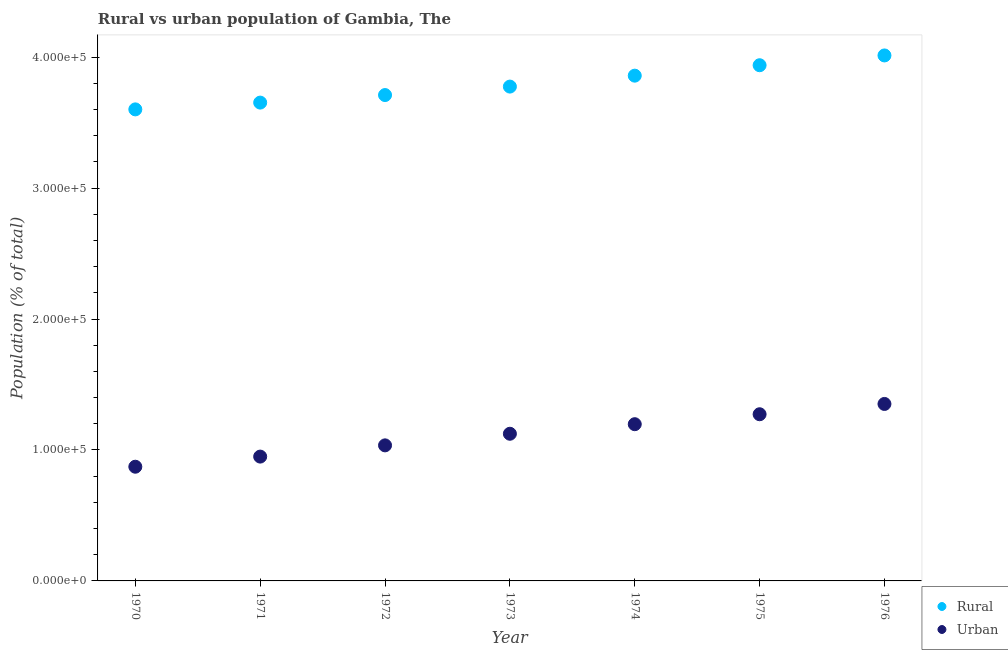What is the rural population density in 1970?
Offer a terse response. 3.60e+05. Across all years, what is the maximum rural population density?
Provide a short and direct response. 4.01e+05. Across all years, what is the minimum urban population density?
Keep it short and to the point. 8.72e+04. In which year was the rural population density maximum?
Ensure brevity in your answer.  1976. What is the total rural population density in the graph?
Your answer should be compact. 2.65e+06. What is the difference between the rural population density in 1972 and that in 1974?
Offer a very short reply. -1.48e+04. What is the difference between the rural population density in 1970 and the urban population density in 1971?
Offer a terse response. 2.65e+05. What is the average urban population density per year?
Offer a terse response. 1.11e+05. In the year 1973, what is the difference between the rural population density and urban population density?
Offer a terse response. 2.65e+05. What is the ratio of the urban population density in 1970 to that in 1975?
Provide a succinct answer. 0.69. Is the urban population density in 1971 less than that in 1976?
Your response must be concise. Yes. Is the difference between the urban population density in 1970 and 1976 greater than the difference between the rural population density in 1970 and 1976?
Your answer should be very brief. No. What is the difference between the highest and the second highest rural population density?
Offer a terse response. 7478. What is the difference between the highest and the lowest rural population density?
Provide a succinct answer. 4.12e+04. In how many years, is the urban population density greater than the average urban population density taken over all years?
Your response must be concise. 4. Is the sum of the rural population density in 1970 and 1972 greater than the maximum urban population density across all years?
Your response must be concise. Yes. Does the urban population density monotonically increase over the years?
Provide a succinct answer. Yes. Is the urban population density strictly greater than the rural population density over the years?
Give a very brief answer. No. Are the values on the major ticks of Y-axis written in scientific E-notation?
Your answer should be very brief. Yes. Does the graph contain any zero values?
Your answer should be very brief. No. How are the legend labels stacked?
Keep it short and to the point. Vertical. What is the title of the graph?
Your response must be concise. Rural vs urban population of Gambia, The. Does "Secondary school" appear as one of the legend labels in the graph?
Make the answer very short. No. What is the label or title of the Y-axis?
Make the answer very short. Population (% of total). What is the Population (% of total) of Rural in 1970?
Provide a short and direct response. 3.60e+05. What is the Population (% of total) in Urban in 1970?
Offer a very short reply. 8.72e+04. What is the Population (% of total) of Rural in 1971?
Provide a succinct answer. 3.65e+05. What is the Population (% of total) in Urban in 1971?
Provide a short and direct response. 9.49e+04. What is the Population (% of total) in Rural in 1972?
Ensure brevity in your answer.  3.71e+05. What is the Population (% of total) in Urban in 1972?
Your answer should be compact. 1.04e+05. What is the Population (% of total) of Rural in 1973?
Your answer should be compact. 3.77e+05. What is the Population (% of total) in Urban in 1973?
Offer a terse response. 1.12e+05. What is the Population (% of total) in Rural in 1974?
Give a very brief answer. 3.86e+05. What is the Population (% of total) in Urban in 1974?
Give a very brief answer. 1.20e+05. What is the Population (% of total) of Rural in 1975?
Provide a short and direct response. 3.94e+05. What is the Population (% of total) in Urban in 1975?
Make the answer very short. 1.27e+05. What is the Population (% of total) in Rural in 1976?
Make the answer very short. 4.01e+05. What is the Population (% of total) in Urban in 1976?
Give a very brief answer. 1.35e+05. Across all years, what is the maximum Population (% of total) of Rural?
Offer a terse response. 4.01e+05. Across all years, what is the maximum Population (% of total) of Urban?
Offer a terse response. 1.35e+05. Across all years, what is the minimum Population (% of total) of Rural?
Ensure brevity in your answer.  3.60e+05. Across all years, what is the minimum Population (% of total) in Urban?
Keep it short and to the point. 8.72e+04. What is the total Population (% of total) of Rural in the graph?
Provide a short and direct response. 2.65e+06. What is the total Population (% of total) of Urban in the graph?
Your answer should be very brief. 7.80e+05. What is the difference between the Population (% of total) in Rural in 1970 and that in 1971?
Provide a short and direct response. -5174. What is the difference between the Population (% of total) of Urban in 1970 and that in 1971?
Offer a very short reply. -7736. What is the difference between the Population (% of total) in Rural in 1970 and that in 1972?
Keep it short and to the point. -1.09e+04. What is the difference between the Population (% of total) in Urban in 1970 and that in 1972?
Your response must be concise. -1.63e+04. What is the difference between the Population (% of total) in Rural in 1970 and that in 1973?
Your answer should be very brief. -1.74e+04. What is the difference between the Population (% of total) of Urban in 1970 and that in 1973?
Keep it short and to the point. -2.52e+04. What is the difference between the Population (% of total) in Rural in 1970 and that in 1974?
Make the answer very short. -2.58e+04. What is the difference between the Population (% of total) of Urban in 1970 and that in 1974?
Give a very brief answer. -3.25e+04. What is the difference between the Population (% of total) in Rural in 1970 and that in 1975?
Provide a succinct answer. -3.37e+04. What is the difference between the Population (% of total) in Urban in 1970 and that in 1975?
Your answer should be very brief. -4.01e+04. What is the difference between the Population (% of total) of Rural in 1970 and that in 1976?
Offer a terse response. -4.12e+04. What is the difference between the Population (% of total) in Urban in 1970 and that in 1976?
Ensure brevity in your answer.  -4.79e+04. What is the difference between the Population (% of total) in Rural in 1971 and that in 1972?
Your answer should be compact. -5767. What is the difference between the Population (% of total) in Urban in 1971 and that in 1972?
Offer a terse response. -8578. What is the difference between the Population (% of total) of Rural in 1971 and that in 1973?
Keep it short and to the point. -1.22e+04. What is the difference between the Population (% of total) of Urban in 1971 and that in 1973?
Give a very brief answer. -1.74e+04. What is the difference between the Population (% of total) in Rural in 1971 and that in 1974?
Your answer should be compact. -2.06e+04. What is the difference between the Population (% of total) in Urban in 1971 and that in 1974?
Offer a very short reply. -2.47e+04. What is the difference between the Population (% of total) of Rural in 1971 and that in 1975?
Make the answer very short. -2.85e+04. What is the difference between the Population (% of total) in Urban in 1971 and that in 1975?
Your answer should be very brief. -3.23e+04. What is the difference between the Population (% of total) in Rural in 1971 and that in 1976?
Make the answer very short. -3.60e+04. What is the difference between the Population (% of total) of Urban in 1971 and that in 1976?
Your answer should be very brief. -4.02e+04. What is the difference between the Population (% of total) of Rural in 1972 and that in 1973?
Your answer should be very brief. -6459. What is the difference between the Population (% of total) in Urban in 1972 and that in 1973?
Provide a short and direct response. -8863. What is the difference between the Population (% of total) of Rural in 1972 and that in 1974?
Your answer should be compact. -1.48e+04. What is the difference between the Population (% of total) in Urban in 1972 and that in 1974?
Offer a terse response. -1.62e+04. What is the difference between the Population (% of total) in Rural in 1972 and that in 1975?
Ensure brevity in your answer.  -2.28e+04. What is the difference between the Population (% of total) in Urban in 1972 and that in 1975?
Make the answer very short. -2.38e+04. What is the difference between the Population (% of total) in Rural in 1972 and that in 1976?
Offer a terse response. -3.02e+04. What is the difference between the Population (% of total) of Urban in 1972 and that in 1976?
Provide a short and direct response. -3.16e+04. What is the difference between the Population (% of total) in Rural in 1973 and that in 1974?
Provide a short and direct response. -8351. What is the difference between the Population (% of total) in Urban in 1973 and that in 1974?
Your answer should be very brief. -7301. What is the difference between the Population (% of total) of Rural in 1973 and that in 1975?
Your response must be concise. -1.63e+04. What is the difference between the Population (% of total) of Urban in 1973 and that in 1975?
Give a very brief answer. -1.49e+04. What is the difference between the Population (% of total) in Rural in 1973 and that in 1976?
Your response must be concise. -2.38e+04. What is the difference between the Population (% of total) of Urban in 1973 and that in 1976?
Make the answer very short. -2.28e+04. What is the difference between the Population (% of total) of Rural in 1974 and that in 1975?
Ensure brevity in your answer.  -7961. What is the difference between the Population (% of total) in Urban in 1974 and that in 1975?
Make the answer very short. -7597. What is the difference between the Population (% of total) of Rural in 1974 and that in 1976?
Your answer should be very brief. -1.54e+04. What is the difference between the Population (% of total) of Urban in 1974 and that in 1976?
Offer a terse response. -1.55e+04. What is the difference between the Population (% of total) of Rural in 1975 and that in 1976?
Offer a terse response. -7478. What is the difference between the Population (% of total) of Urban in 1975 and that in 1976?
Offer a terse response. -7861. What is the difference between the Population (% of total) of Rural in 1970 and the Population (% of total) of Urban in 1971?
Make the answer very short. 2.65e+05. What is the difference between the Population (% of total) in Rural in 1970 and the Population (% of total) in Urban in 1972?
Make the answer very short. 2.57e+05. What is the difference between the Population (% of total) in Rural in 1970 and the Population (% of total) in Urban in 1973?
Keep it short and to the point. 2.48e+05. What is the difference between the Population (% of total) in Rural in 1970 and the Population (% of total) in Urban in 1974?
Your answer should be very brief. 2.40e+05. What is the difference between the Population (% of total) of Rural in 1970 and the Population (% of total) of Urban in 1975?
Offer a very short reply. 2.33e+05. What is the difference between the Population (% of total) of Rural in 1970 and the Population (% of total) of Urban in 1976?
Give a very brief answer. 2.25e+05. What is the difference between the Population (% of total) in Rural in 1971 and the Population (% of total) in Urban in 1972?
Keep it short and to the point. 2.62e+05. What is the difference between the Population (% of total) of Rural in 1971 and the Population (% of total) of Urban in 1973?
Make the answer very short. 2.53e+05. What is the difference between the Population (% of total) of Rural in 1971 and the Population (% of total) of Urban in 1974?
Provide a succinct answer. 2.46e+05. What is the difference between the Population (% of total) of Rural in 1971 and the Population (% of total) of Urban in 1975?
Make the answer very short. 2.38e+05. What is the difference between the Population (% of total) in Rural in 1971 and the Population (% of total) in Urban in 1976?
Make the answer very short. 2.30e+05. What is the difference between the Population (% of total) of Rural in 1972 and the Population (% of total) of Urban in 1973?
Ensure brevity in your answer.  2.59e+05. What is the difference between the Population (% of total) of Rural in 1972 and the Population (% of total) of Urban in 1974?
Provide a succinct answer. 2.51e+05. What is the difference between the Population (% of total) of Rural in 1972 and the Population (% of total) of Urban in 1975?
Ensure brevity in your answer.  2.44e+05. What is the difference between the Population (% of total) in Rural in 1972 and the Population (% of total) in Urban in 1976?
Ensure brevity in your answer.  2.36e+05. What is the difference between the Population (% of total) in Rural in 1973 and the Population (% of total) in Urban in 1974?
Your response must be concise. 2.58e+05. What is the difference between the Population (% of total) in Rural in 1973 and the Population (% of total) in Urban in 1975?
Offer a very short reply. 2.50e+05. What is the difference between the Population (% of total) in Rural in 1973 and the Population (% of total) in Urban in 1976?
Your answer should be compact. 2.42e+05. What is the difference between the Population (% of total) in Rural in 1974 and the Population (% of total) in Urban in 1975?
Provide a short and direct response. 2.59e+05. What is the difference between the Population (% of total) in Rural in 1974 and the Population (% of total) in Urban in 1976?
Your answer should be compact. 2.51e+05. What is the difference between the Population (% of total) in Rural in 1975 and the Population (% of total) in Urban in 1976?
Ensure brevity in your answer.  2.59e+05. What is the average Population (% of total) of Rural per year?
Offer a terse response. 3.79e+05. What is the average Population (% of total) in Urban per year?
Your answer should be compact. 1.11e+05. In the year 1970, what is the difference between the Population (% of total) in Rural and Population (% of total) in Urban?
Keep it short and to the point. 2.73e+05. In the year 1971, what is the difference between the Population (% of total) of Rural and Population (% of total) of Urban?
Provide a succinct answer. 2.70e+05. In the year 1972, what is the difference between the Population (% of total) in Rural and Population (% of total) in Urban?
Provide a succinct answer. 2.68e+05. In the year 1973, what is the difference between the Population (% of total) of Rural and Population (% of total) of Urban?
Your answer should be compact. 2.65e+05. In the year 1974, what is the difference between the Population (% of total) of Rural and Population (% of total) of Urban?
Provide a short and direct response. 2.66e+05. In the year 1975, what is the difference between the Population (% of total) of Rural and Population (% of total) of Urban?
Provide a short and direct response. 2.67e+05. In the year 1976, what is the difference between the Population (% of total) of Rural and Population (% of total) of Urban?
Give a very brief answer. 2.66e+05. What is the ratio of the Population (% of total) of Rural in 1970 to that in 1971?
Ensure brevity in your answer.  0.99. What is the ratio of the Population (% of total) in Urban in 1970 to that in 1971?
Keep it short and to the point. 0.92. What is the ratio of the Population (% of total) in Rural in 1970 to that in 1972?
Make the answer very short. 0.97. What is the ratio of the Population (% of total) of Urban in 1970 to that in 1972?
Provide a succinct answer. 0.84. What is the ratio of the Population (% of total) of Rural in 1970 to that in 1973?
Make the answer very short. 0.95. What is the ratio of the Population (% of total) in Urban in 1970 to that in 1973?
Provide a short and direct response. 0.78. What is the ratio of the Population (% of total) in Rural in 1970 to that in 1974?
Offer a terse response. 0.93. What is the ratio of the Population (% of total) in Urban in 1970 to that in 1974?
Make the answer very short. 0.73. What is the ratio of the Population (% of total) in Rural in 1970 to that in 1975?
Keep it short and to the point. 0.91. What is the ratio of the Population (% of total) of Urban in 1970 to that in 1975?
Offer a very short reply. 0.69. What is the ratio of the Population (% of total) of Rural in 1970 to that in 1976?
Make the answer very short. 0.9. What is the ratio of the Population (% of total) in Urban in 1970 to that in 1976?
Make the answer very short. 0.65. What is the ratio of the Population (% of total) in Rural in 1971 to that in 1972?
Your response must be concise. 0.98. What is the ratio of the Population (% of total) in Urban in 1971 to that in 1972?
Offer a terse response. 0.92. What is the ratio of the Population (% of total) in Rural in 1971 to that in 1973?
Your response must be concise. 0.97. What is the ratio of the Population (% of total) in Urban in 1971 to that in 1973?
Ensure brevity in your answer.  0.84. What is the ratio of the Population (% of total) in Rural in 1971 to that in 1974?
Your answer should be compact. 0.95. What is the ratio of the Population (% of total) in Urban in 1971 to that in 1974?
Give a very brief answer. 0.79. What is the ratio of the Population (% of total) of Rural in 1971 to that in 1975?
Ensure brevity in your answer.  0.93. What is the ratio of the Population (% of total) in Urban in 1971 to that in 1975?
Offer a very short reply. 0.75. What is the ratio of the Population (% of total) in Rural in 1971 to that in 1976?
Provide a short and direct response. 0.91. What is the ratio of the Population (% of total) in Urban in 1971 to that in 1976?
Offer a terse response. 0.7. What is the ratio of the Population (% of total) of Rural in 1972 to that in 1973?
Keep it short and to the point. 0.98. What is the ratio of the Population (% of total) in Urban in 1972 to that in 1973?
Offer a terse response. 0.92. What is the ratio of the Population (% of total) of Rural in 1972 to that in 1974?
Keep it short and to the point. 0.96. What is the ratio of the Population (% of total) in Urban in 1972 to that in 1974?
Your answer should be very brief. 0.86. What is the ratio of the Population (% of total) in Rural in 1972 to that in 1975?
Provide a short and direct response. 0.94. What is the ratio of the Population (% of total) of Urban in 1972 to that in 1975?
Give a very brief answer. 0.81. What is the ratio of the Population (% of total) of Rural in 1972 to that in 1976?
Make the answer very short. 0.92. What is the ratio of the Population (% of total) in Urban in 1972 to that in 1976?
Offer a terse response. 0.77. What is the ratio of the Population (% of total) in Rural in 1973 to that in 1974?
Make the answer very short. 0.98. What is the ratio of the Population (% of total) of Urban in 1973 to that in 1974?
Keep it short and to the point. 0.94. What is the ratio of the Population (% of total) in Rural in 1973 to that in 1975?
Offer a very short reply. 0.96. What is the ratio of the Population (% of total) of Urban in 1973 to that in 1975?
Your response must be concise. 0.88. What is the ratio of the Population (% of total) of Rural in 1973 to that in 1976?
Ensure brevity in your answer.  0.94. What is the ratio of the Population (% of total) of Urban in 1973 to that in 1976?
Ensure brevity in your answer.  0.83. What is the ratio of the Population (% of total) in Rural in 1974 to that in 1975?
Make the answer very short. 0.98. What is the ratio of the Population (% of total) of Urban in 1974 to that in 1975?
Ensure brevity in your answer.  0.94. What is the ratio of the Population (% of total) of Rural in 1974 to that in 1976?
Keep it short and to the point. 0.96. What is the ratio of the Population (% of total) of Urban in 1974 to that in 1976?
Your answer should be compact. 0.89. What is the ratio of the Population (% of total) of Rural in 1975 to that in 1976?
Your answer should be very brief. 0.98. What is the ratio of the Population (% of total) of Urban in 1975 to that in 1976?
Your response must be concise. 0.94. What is the difference between the highest and the second highest Population (% of total) in Rural?
Ensure brevity in your answer.  7478. What is the difference between the highest and the second highest Population (% of total) of Urban?
Your response must be concise. 7861. What is the difference between the highest and the lowest Population (% of total) in Rural?
Make the answer very short. 4.12e+04. What is the difference between the highest and the lowest Population (% of total) in Urban?
Provide a short and direct response. 4.79e+04. 